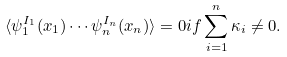<formula> <loc_0><loc_0><loc_500><loc_500>\langle \psi _ { 1 } ^ { I _ { 1 } } ( x _ { 1 } ) \cdots \psi _ { n } ^ { I _ { n } } ( x _ { n } ) \rangle = 0 i f \sum _ { i = 1 } ^ { n } \kappa _ { i } \neq 0 .</formula> 